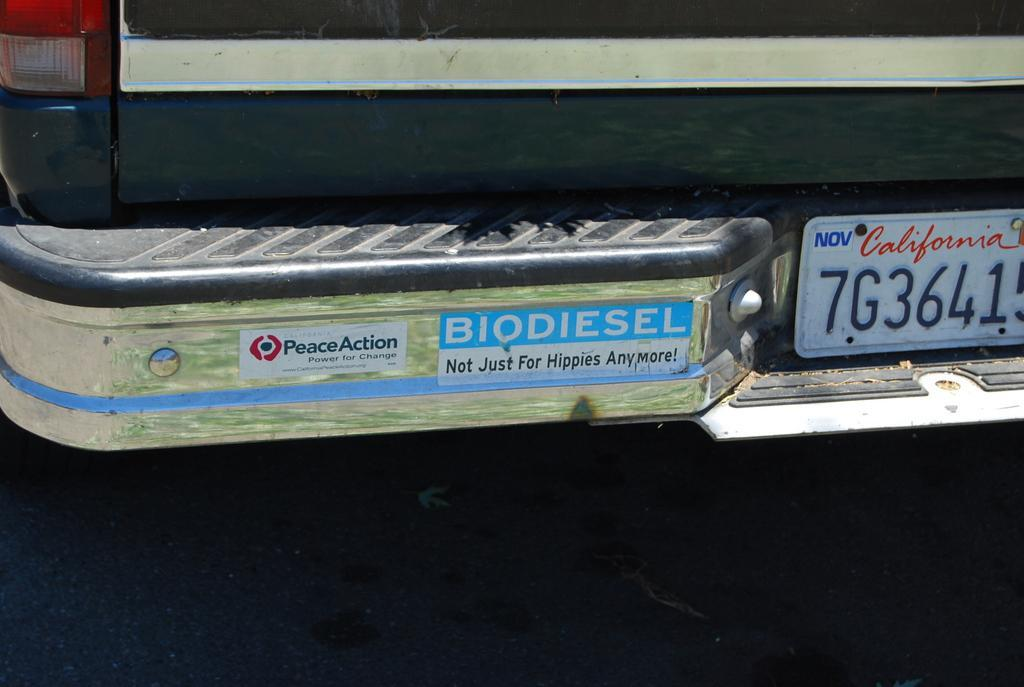<image>
Provide a brief description of the given image. A car from California that reads BIODIESEL Not Just For Hippies Anymore! 